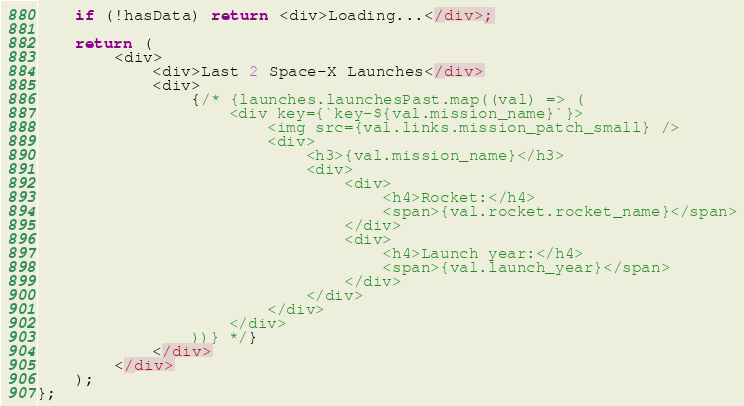<code> <loc_0><loc_0><loc_500><loc_500><_TypeScript_>
    if (!hasData) return <div>Loading...</div>;

    return (
        <div>
            <div>Last 2 Space-X Launches</div>
            <div>
                {/* {launches.launchesPast.map((val) => (
                    <div key={`key-${val.mission_name}`}>
                        <img src={val.links.mission_patch_small} />
                        <div>
                            <h3>{val.mission_name}</h3>
                            <div>
                                <div>
                                    <h4>Rocket:</h4>
                                    <span>{val.rocket.rocket_name}</span>
                                </div>
                                <div>
                                    <h4>Launch year:</h4>
                                    <span>{val.launch_year}</span>
                                </div>
                            </div>
                        </div>
                    </div>
                ))} */}
            </div>
        </div>
    );
};
</code> 